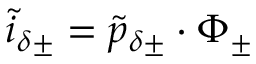Convert formula to latex. <formula><loc_0><loc_0><loc_500><loc_500>\tilde { i } _ { \delta \pm } = \tilde { p } _ { \delta \pm } \cdot \Phi _ { \pm }</formula> 